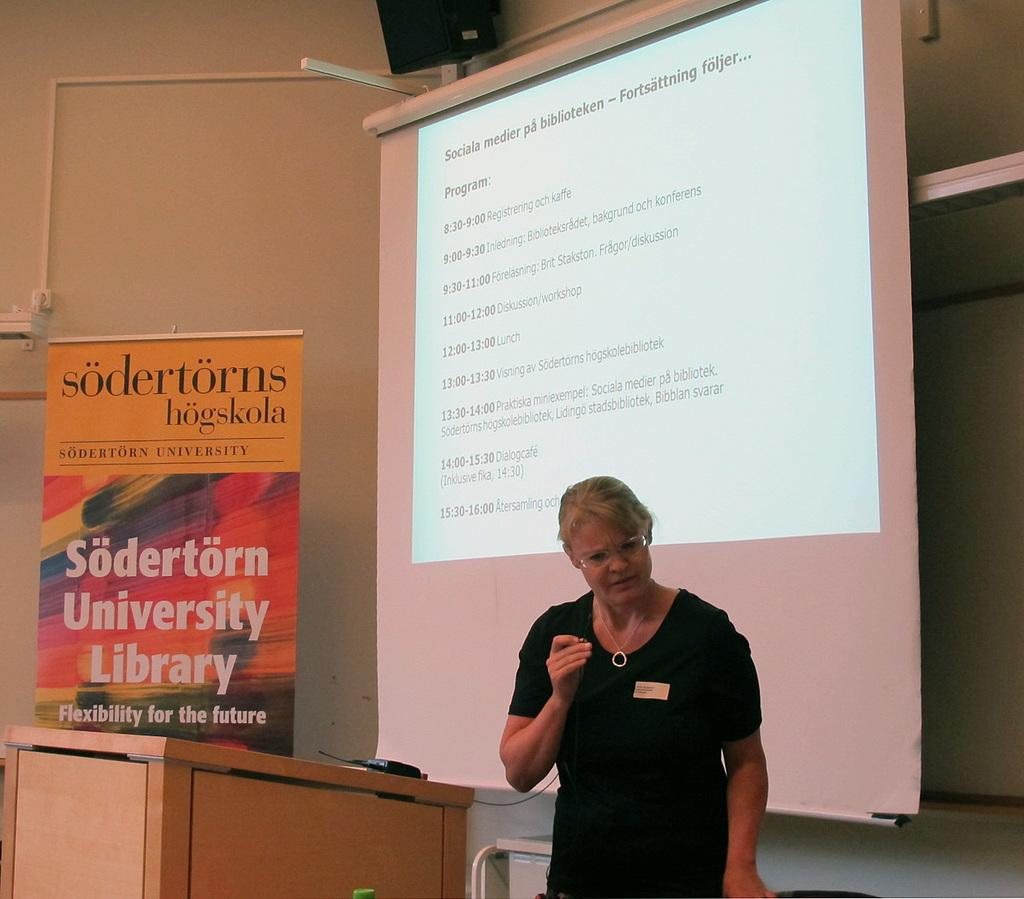<image>
Write a terse but informative summary of the picture. a woman standing in front of a projector and a sign for "Sodertons Hogskola". 